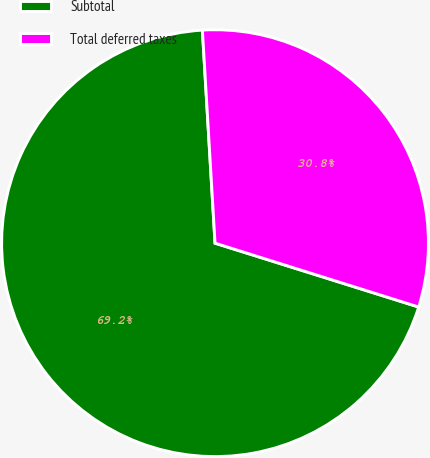Convert chart. <chart><loc_0><loc_0><loc_500><loc_500><pie_chart><fcel>Subtotal<fcel>Total deferred taxes<nl><fcel>69.22%<fcel>30.78%<nl></chart> 